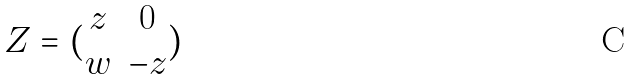<formula> <loc_0><loc_0><loc_500><loc_500>Z = ( \begin{matrix} z & 0 \\ w & - z \end{matrix} )</formula> 